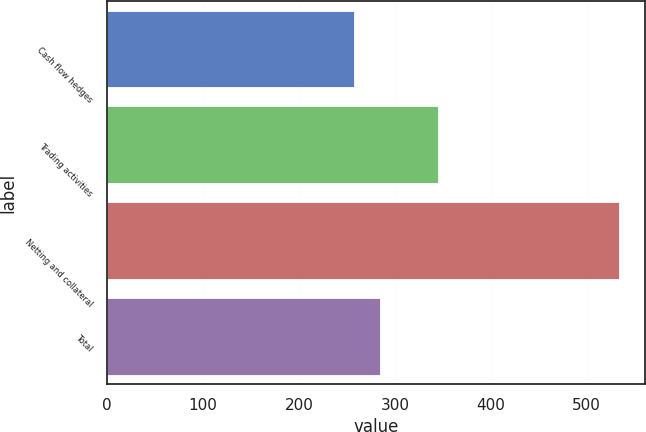Convert chart. <chart><loc_0><loc_0><loc_500><loc_500><bar_chart><fcel>Cash flow hedges<fcel>Trading activities<fcel>Netting and collateral<fcel>Total<nl><fcel>257<fcel>345<fcel>534<fcel>284.7<nl></chart> 